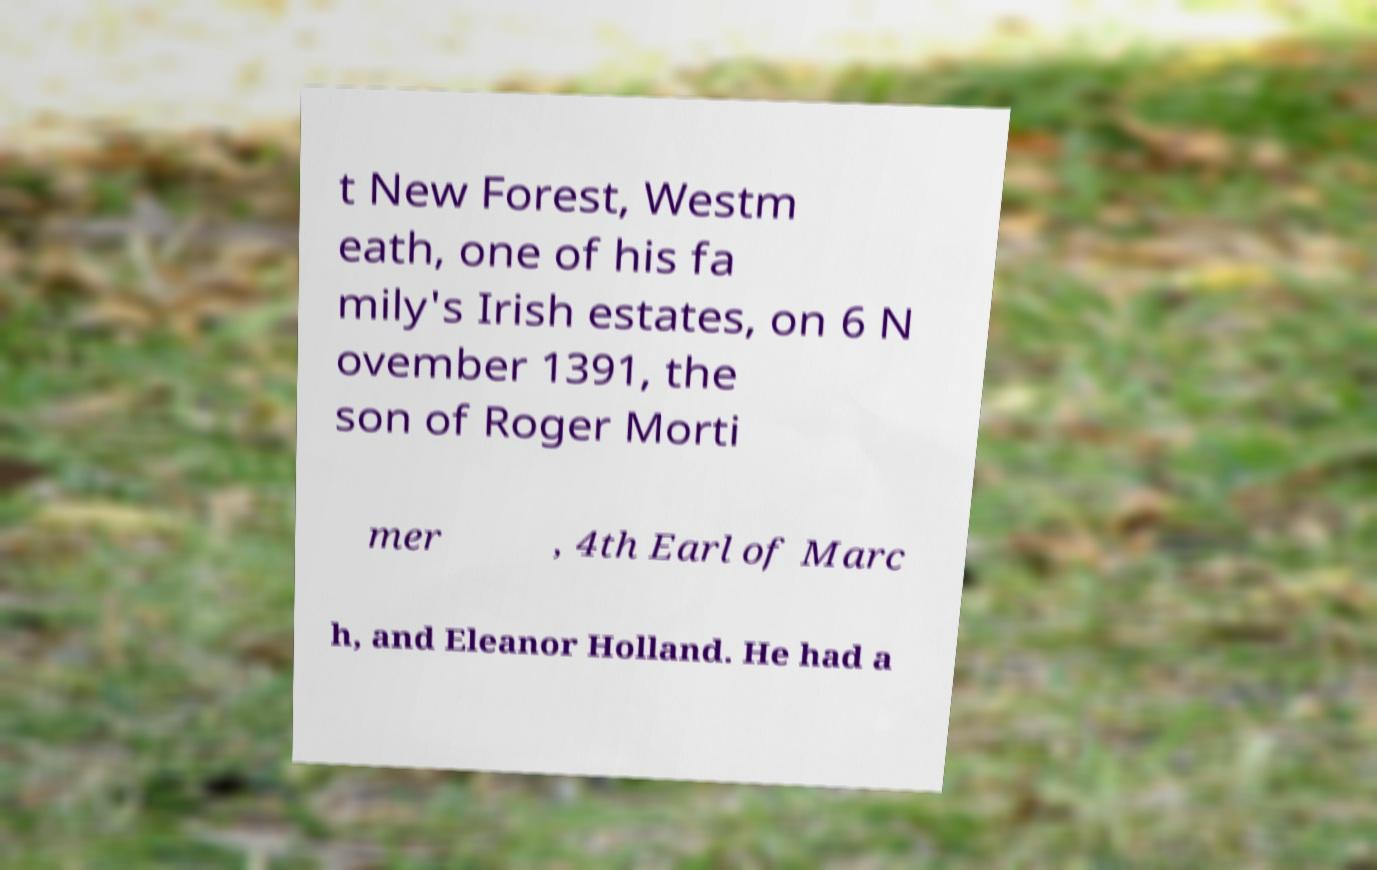Can you read and provide the text displayed in the image?This photo seems to have some interesting text. Can you extract and type it out for me? t New Forest, Westm eath, one of his fa mily's Irish estates, on 6 N ovember 1391, the son of Roger Morti mer , 4th Earl of Marc h, and Eleanor Holland. He had a 